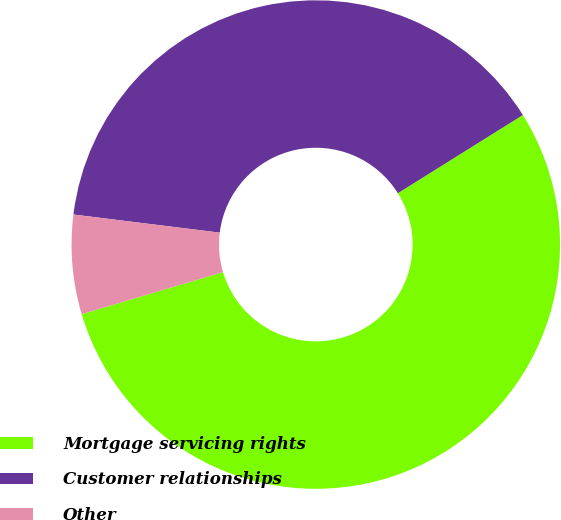Convert chart to OTSL. <chart><loc_0><loc_0><loc_500><loc_500><pie_chart><fcel>Mortgage servicing rights<fcel>Customer relationships<fcel>Other<nl><fcel>54.3%<fcel>39.14%<fcel>6.56%<nl></chart> 